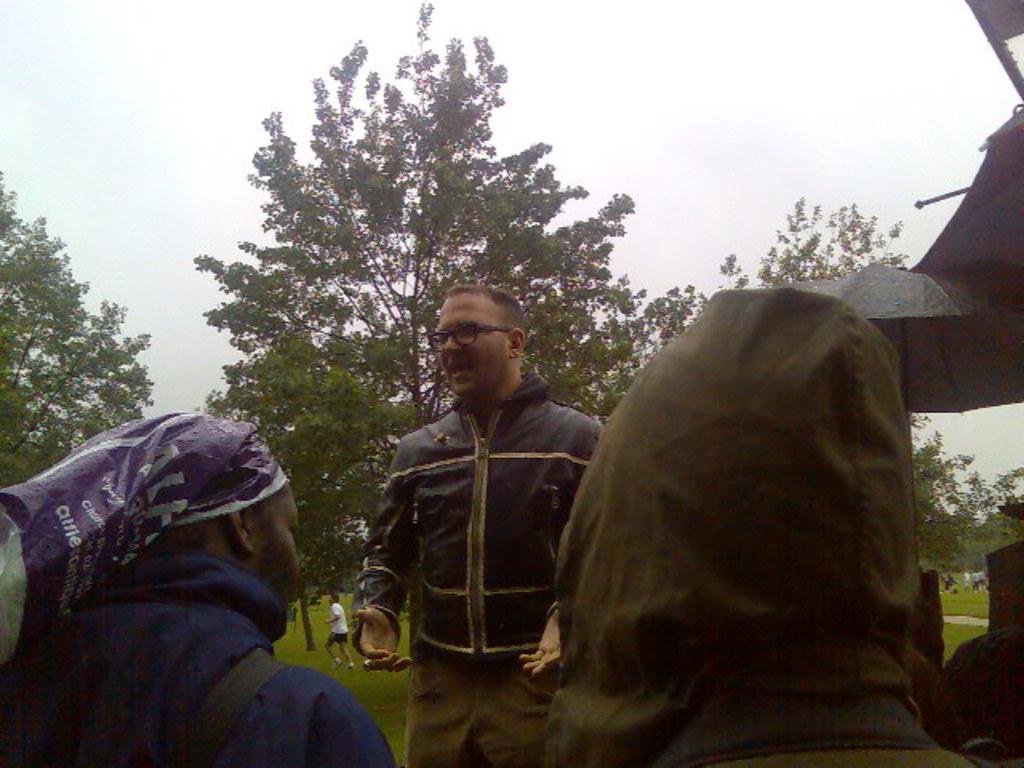Describe this image in one or two sentences. In this image in front there are people. Behind them there are trees. In the background of the image there is sky. On the right side of the image there is an umbrella and there is some object. 